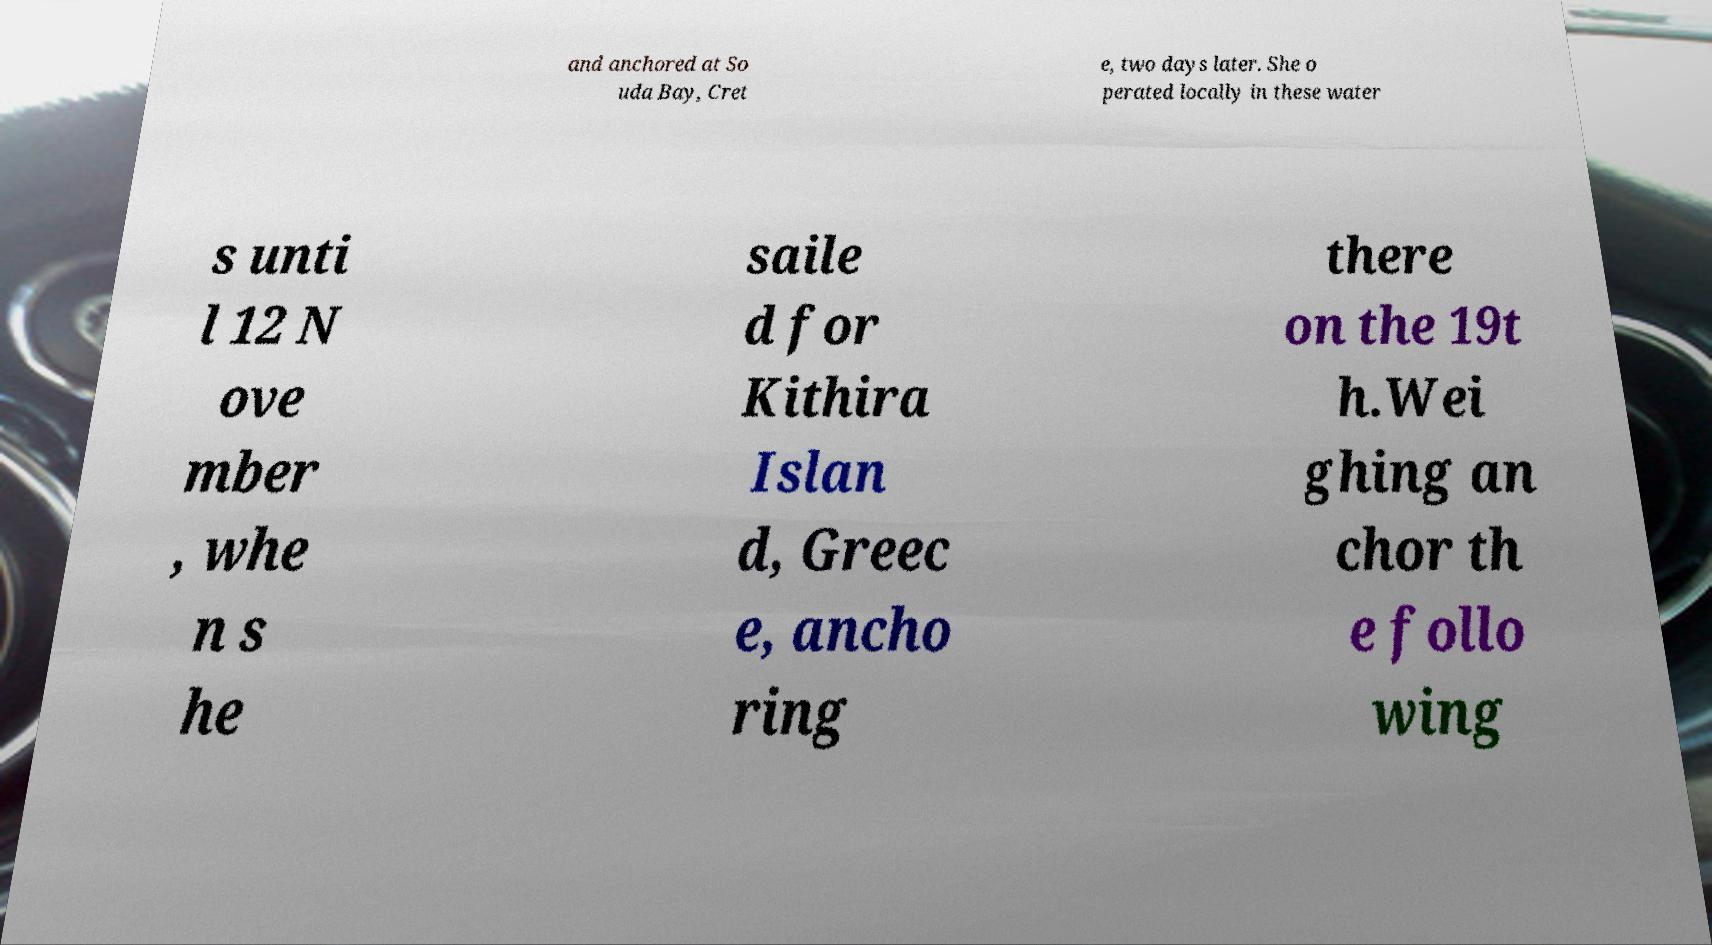What messages or text are displayed in this image? I need them in a readable, typed format. and anchored at So uda Bay, Cret e, two days later. She o perated locally in these water s unti l 12 N ove mber , whe n s he saile d for Kithira Islan d, Greec e, ancho ring there on the 19t h.Wei ghing an chor th e follo wing 